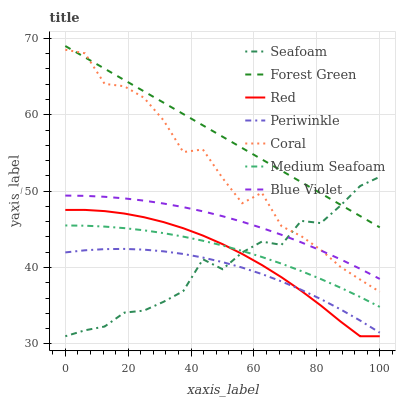Does Periwinkle have the minimum area under the curve?
Answer yes or no. Yes. Does Forest Green have the maximum area under the curve?
Answer yes or no. Yes. Does Seafoam have the minimum area under the curve?
Answer yes or no. No. Does Seafoam have the maximum area under the curve?
Answer yes or no. No. Is Forest Green the smoothest?
Answer yes or no. Yes. Is Coral the roughest?
Answer yes or no. Yes. Is Seafoam the smoothest?
Answer yes or no. No. Is Seafoam the roughest?
Answer yes or no. No. Does Seafoam have the lowest value?
Answer yes or no. Yes. Does Forest Green have the lowest value?
Answer yes or no. No. Does Forest Green have the highest value?
Answer yes or no. Yes. Does Seafoam have the highest value?
Answer yes or no. No. Is Medium Seafoam less than Forest Green?
Answer yes or no. Yes. Is Forest Green greater than Periwinkle?
Answer yes or no. Yes. Does Blue Violet intersect Coral?
Answer yes or no. Yes. Is Blue Violet less than Coral?
Answer yes or no. No. Is Blue Violet greater than Coral?
Answer yes or no. No. Does Medium Seafoam intersect Forest Green?
Answer yes or no. No. 